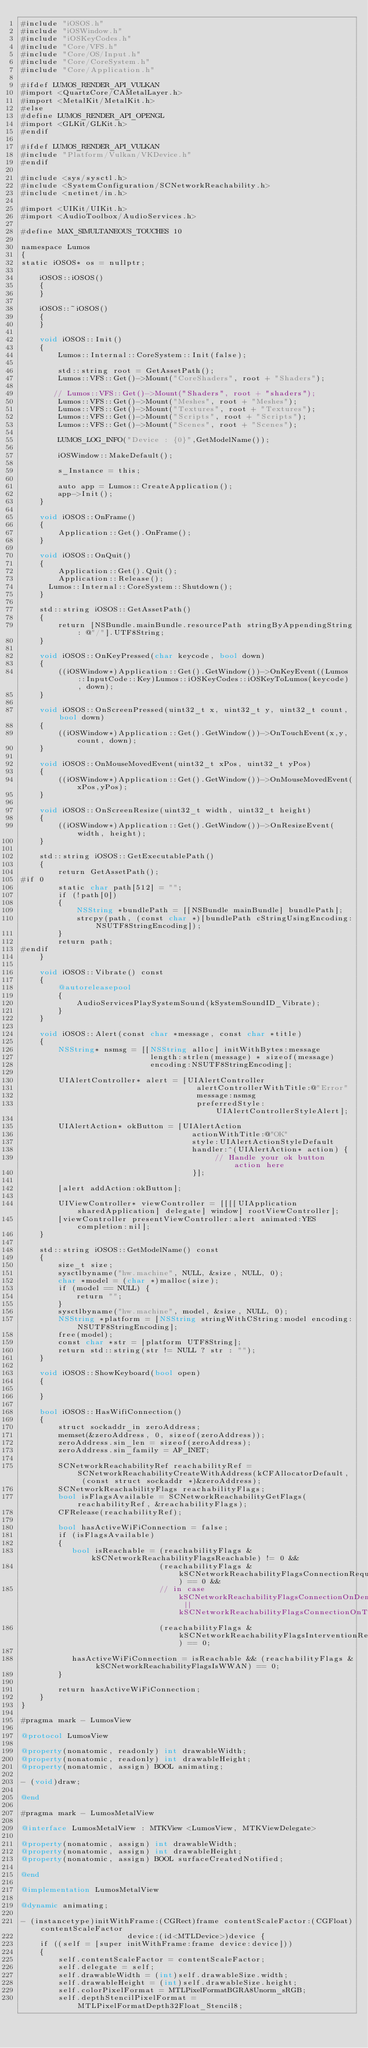<code> <loc_0><loc_0><loc_500><loc_500><_ObjectiveC_>#include "iOSOS.h"
#include "iOSWindow.h"
#include "iOSKeyCodes.h"
#include "Core/VFS.h"
#include "Core/OS/Input.h"
#include "Core/CoreSystem.h"
#include "Core/Application.h"

#ifdef LUMOS_RENDER_API_VULKAN
#import <QuartzCore/CAMetalLayer.h>
#import <MetalKit/MetalKit.h>
#else
#define LUMOS_RENDER_API_OPENGL
#import <GLKit/GLKit.h>
#endif

#ifdef LUMOS_RENDER_API_VULKAN
#include "Platform/Vulkan/VKDevice.h"
#endif

#include <sys/sysctl.h>
#include <SystemConfiguration/SCNetworkReachability.h>
#include <netinet/in.h>

#import <UIKit/UIKit.h>
#import <AudioToolbox/AudioServices.h>

#define MAX_SIMULTANEOUS_TOUCHES 10

namespace Lumos
{
static iOSOS* os = nullptr;

    iOSOS::iOSOS()
    {
    }

    iOSOS::~iOSOS()
    {
    }

    void iOSOS::Init()
    {
        Lumos::Internal::CoreSystem::Init(false);

        std::string root = GetAssetPath();
        Lumos::VFS::Get()->Mount("CoreShaders", root + "Shaders");

       // Lumos::VFS::Get()->Mount("Shaders", root + "shaders");
        Lumos::VFS::Get()->Mount("Meshes", root + "Meshes");
        Lumos::VFS::Get()->Mount("Textures", root + "Textures");
        Lumos::VFS::Get()->Mount("Scripts", root + "Scripts");
        Lumos::VFS::Get()->Mount("Scenes", root + "Scenes");
        
        LUMOS_LOG_INFO("Device : {0}",GetModelName());
        
        iOSWindow::MakeDefault();

        s_Instance = this;

        auto app = Lumos::CreateApplication();
        app->Init();
    }

    void iOSOS::OnFrame()
    {
        Application::Get().OnFrame();
    }
    
    void iOSOS::OnQuit()
    {
        Application::Get().Quit();
        Application::Release();
	    Lumos::Internal::CoreSystem::Shutdown();
    }
    
    std::string iOSOS::GetAssetPath()
    {
        return [NSBundle.mainBundle.resourcePath stringByAppendingString: @"/"].UTF8String;
    }
    
    void iOSOS::OnKeyPressed(char keycode, bool down)
    {
        ((iOSWindow*)Application::Get().GetWindow())->OnKeyEvent((Lumos::InputCode::Key)Lumos::iOSKeyCodes::iOSKeyToLumos(keycode), down);
    }

    void iOSOS::OnScreenPressed(uint32_t x, uint32_t y, uint32_t count, bool down)
    {
        ((iOSWindow*)Application::Get().GetWindow())->OnTouchEvent(x,y,count, down);
    }

    void iOSOS::OnMouseMovedEvent(uint32_t xPos, uint32_t yPos)
    {
        ((iOSWindow*)Application::Get().GetWindow())->OnMouseMovedEvent(xPos,yPos);
    }
    
    void iOSOS::OnScreenResize(uint32_t width, uint32_t height)
    {
        ((iOSWindow*)Application::Get().GetWindow())->OnResizeEvent(width, height);
    }

    std::string iOSOS::GetExecutablePath()
    {
        return GetAssetPath();
#if 0
        static char path[512] = "";
        if (!path[0])
        {
            NSString *bundlePath = [[NSBundle mainBundle] bundlePath];
            strcpy(path, (const char *)[bundlePath cStringUsingEncoding:NSUTF8StringEncoding]);
        }
        return path;
#endif
    }

    void iOSOS::Vibrate() const
    {
        @autoreleasepool
        {
            AudioServicesPlaySystemSound(kSystemSoundID_Vibrate);
        }
    }

    void iOSOS::Alert(const char *message, const char *title)
    {
        NSString* nsmsg = [[NSString alloc] initWithBytes:message
                            length:strlen(message) * sizeof(message)
                            encoding:NSUTF8StringEncoding];
        
        UIAlertController* alert = [UIAlertController
                                      alertControllerWithTitle:@"Error"
                                      message:nsmsg
                                      preferredStyle:UIAlertControllerStyleAlert];
          
        UIAlertAction* okButton = [UIAlertAction
                                     actionWithTitle:@"OK"
                                     style:UIAlertActionStyleDefault
                                     handler:^(UIAlertAction* action) {
                                          // Handle your ok button action here
                                     }];
          
        [alert addAction:okButton];
        
        UIViewController* viewController = [[[[UIApplication sharedApplication] delegate] window] rootViewController];
        [viewController presentViewController:alert animated:YES completion:nil];
    }
    
    std::string iOSOS::GetModelName() const
    {
        size_t size;
        sysctlbyname("hw.machine", NULL, &size, NULL, 0);
        char *model = (char *)malloc(size);
        if (model == NULL) {
            return "";
        }
        sysctlbyname("hw.machine", model, &size, NULL, 0);
        NSString *platform = [NSString stringWithCString:model encoding:NSUTF8StringEncoding];
        free(model);
        const char *str = [platform UTF8String];
        return std::string(str != NULL ? str : "");
    }

    void iOSOS::ShowKeyboard(bool open)
    {
        
    }

    bool iOSOS::HasWifiConnection()
    {
        struct sockaddr_in zeroAddress;
        memset(&zeroAddress, 0, sizeof(zeroAddress));
        zeroAddress.sin_len = sizeof(zeroAddress);
        zeroAddress.sin_family = AF_INET;

        SCNetworkReachabilityRef reachabilityRef = SCNetworkReachabilityCreateWithAddress(kCFAllocatorDefault, (const struct sockaddr *)&zeroAddress);
        SCNetworkReachabilityFlags reachabilityFlags;
        bool isFlagsAvailable = SCNetworkReachabilityGetFlags(reachabilityRef, &reachabilityFlags);
        CFRelease(reachabilityRef);

        bool hasActiveWiFiConnection = false;
        if (isFlagsAvailable)
        {
           bool isReachable = (reachabilityFlags & kSCNetworkReachabilityFlagsReachable) != 0 &&
                              (reachabilityFlags & kSCNetworkReachabilityFlagsConnectionRequired) == 0 &&
                              // in case kSCNetworkReachabilityFlagsConnectionOnDemand || kSCNetworkReachabilityFlagsConnectionOnTraffic
                              (reachabilityFlags & kSCNetworkReachabilityFlagsInterventionRequired) == 0;
                       
           hasActiveWiFiConnection = isReachable && (reachabilityFlags & kSCNetworkReachabilityFlagsIsWWAN) == 0;
        }

        return hasActiveWiFiConnection;
    }
}

#pragma mark - LumosView

@protocol LumosView

@property(nonatomic, readonly) int drawableWidth;
@property(nonatomic, readonly) int drawableHeight;
@property(nonatomic, assign) BOOL animating;

- (void)draw;

@end

#pragma mark - LumosMetalView

@interface LumosMetalView : MTKView <LumosView, MTKViewDelegate>

@property(nonatomic, assign) int drawableWidth;
@property(nonatomic, assign) int drawableHeight;
@property(nonatomic, assign) BOOL surfaceCreatedNotified;

@end

@implementation LumosMetalView

@dynamic animating;

- (instancetype)initWithFrame:(CGRect)frame contentScaleFactor:(CGFloat)contentScaleFactor
                       device:(id<MTLDevice>)device {
    if ((self = [super initWithFrame:frame device:device]))
    {
        self.contentScaleFactor = contentScaleFactor;
        self.delegate = self;
        self.drawableWidth = (int)self.drawableSize.width;
        self.drawableHeight = (int)self.drawableSize.height;
        self.colorPixelFormat = MTLPixelFormatBGRA8Unorm_sRGB;
        self.depthStencilPixelFormat = MTLPixelFormatDepth32Float_Stencil8;</code> 